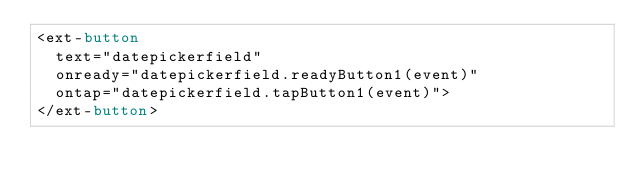<code> <loc_0><loc_0><loc_500><loc_500><_HTML_><ext-button 
  text="datepickerfield"
  onready="datepickerfield.readyButton1(event)"
  ontap="datepickerfield.tapButton1(event)">
</ext-button>
</code> 